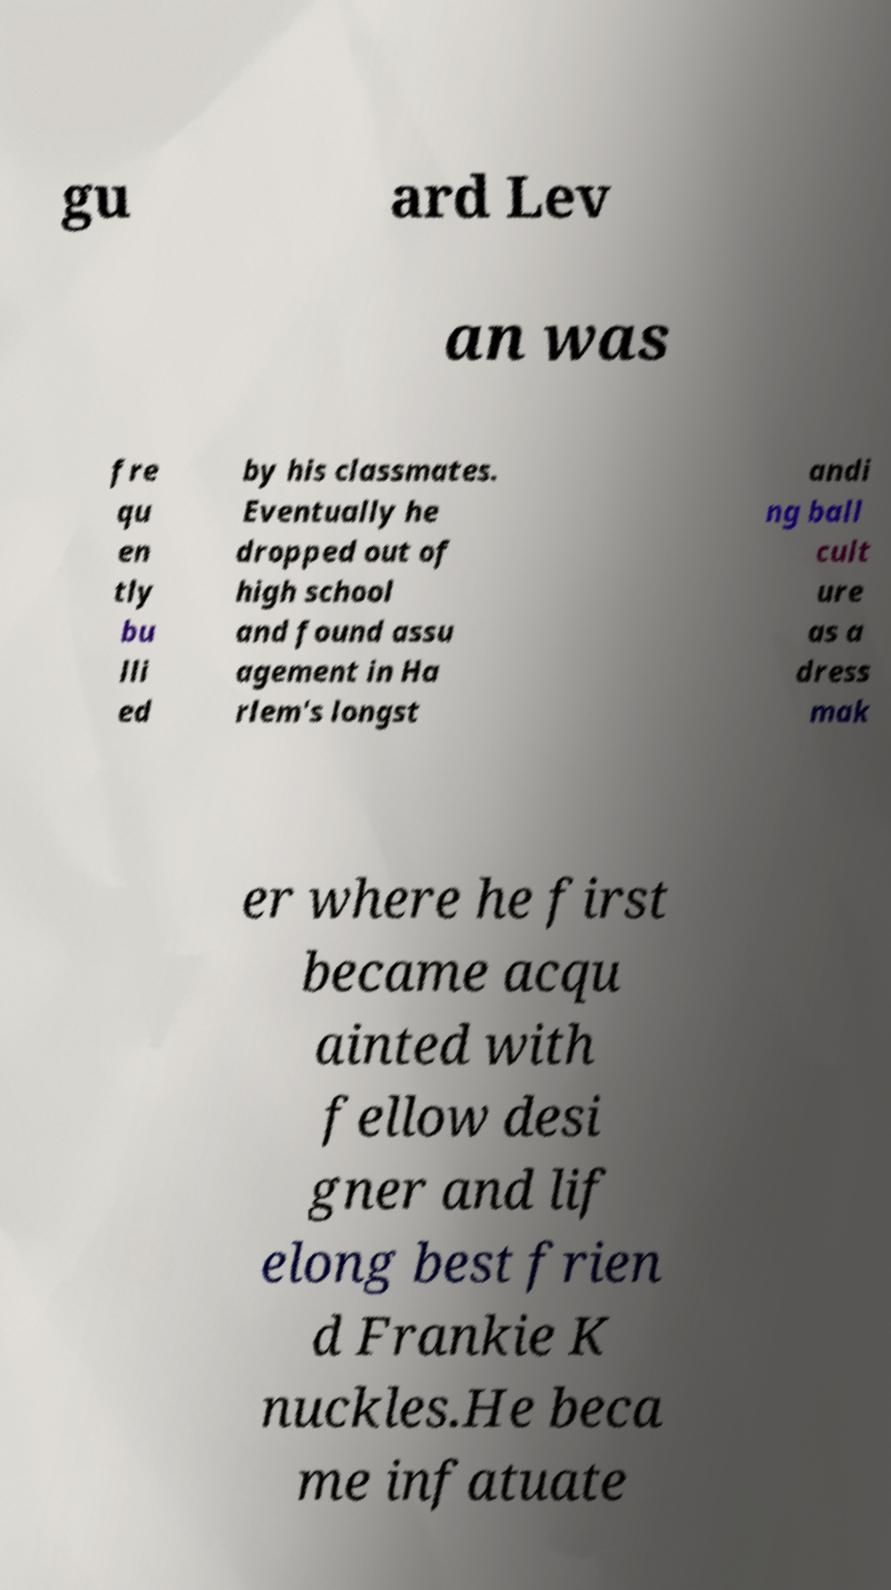Can you read and provide the text displayed in the image?This photo seems to have some interesting text. Can you extract and type it out for me? gu ard Lev an was fre qu en tly bu lli ed by his classmates. Eventually he dropped out of high school and found assu agement in Ha rlem's longst andi ng ball cult ure as a dress mak er where he first became acqu ainted with fellow desi gner and lif elong best frien d Frankie K nuckles.He beca me infatuate 